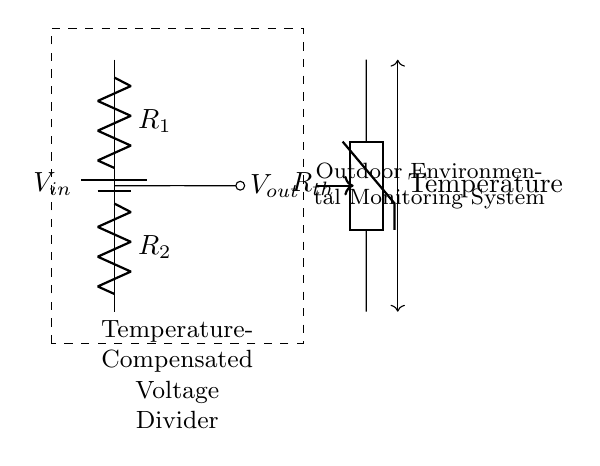What is the input voltage of the circuit? The input voltage, denoted as V_in, is connected to the top terminal of the first resistor R1. According to the circuit diagram, the specific value of V_in is not given, but it represents the voltage provided to the circuit.
Answer: V_in What are the two resistors in the ratio? The two resistors are R1 and R2. They are in series and form the voltage divider, which determines the output voltage based on their values and the input voltage.
Answer: R1 and R2 What component is used for temperature compensation? The temperature compensation in this circuit is provided by the thermistor, labeled as R_th. It changes resistance with temperature, impacting the overall voltage output as temperature varies.
Answer: R_th How does temperature affect the output voltage? Temperature affects the output voltage by altering the resistance of the thermistor, R_th. As temperature changes, the resistance of R_th changes, which in turn affects the voltage division between R1 and R2, leading to a varying output voltage based on environmental conditions.
Answer: By altering R_th What is the output voltage of the voltage divider? The output voltage, denoted as V_out, is taken from the junction between the two resistors R1 and R2. It is determined by the ratio of R1 and R2 in conjunction with the input voltage V_in. The specific voltage cannot be determined without the values of R1, R2, and V_in.
Answer: V_out What purpose does the dashed rectangle serve? The dashed rectangle encapsulates the main components of the temperature-compensated voltage divider, indicating that this section of the circuit is intended for that specific function, providing clarity and focus on the relevant parts of the circuit.
Answer: To enclose the voltage divider 